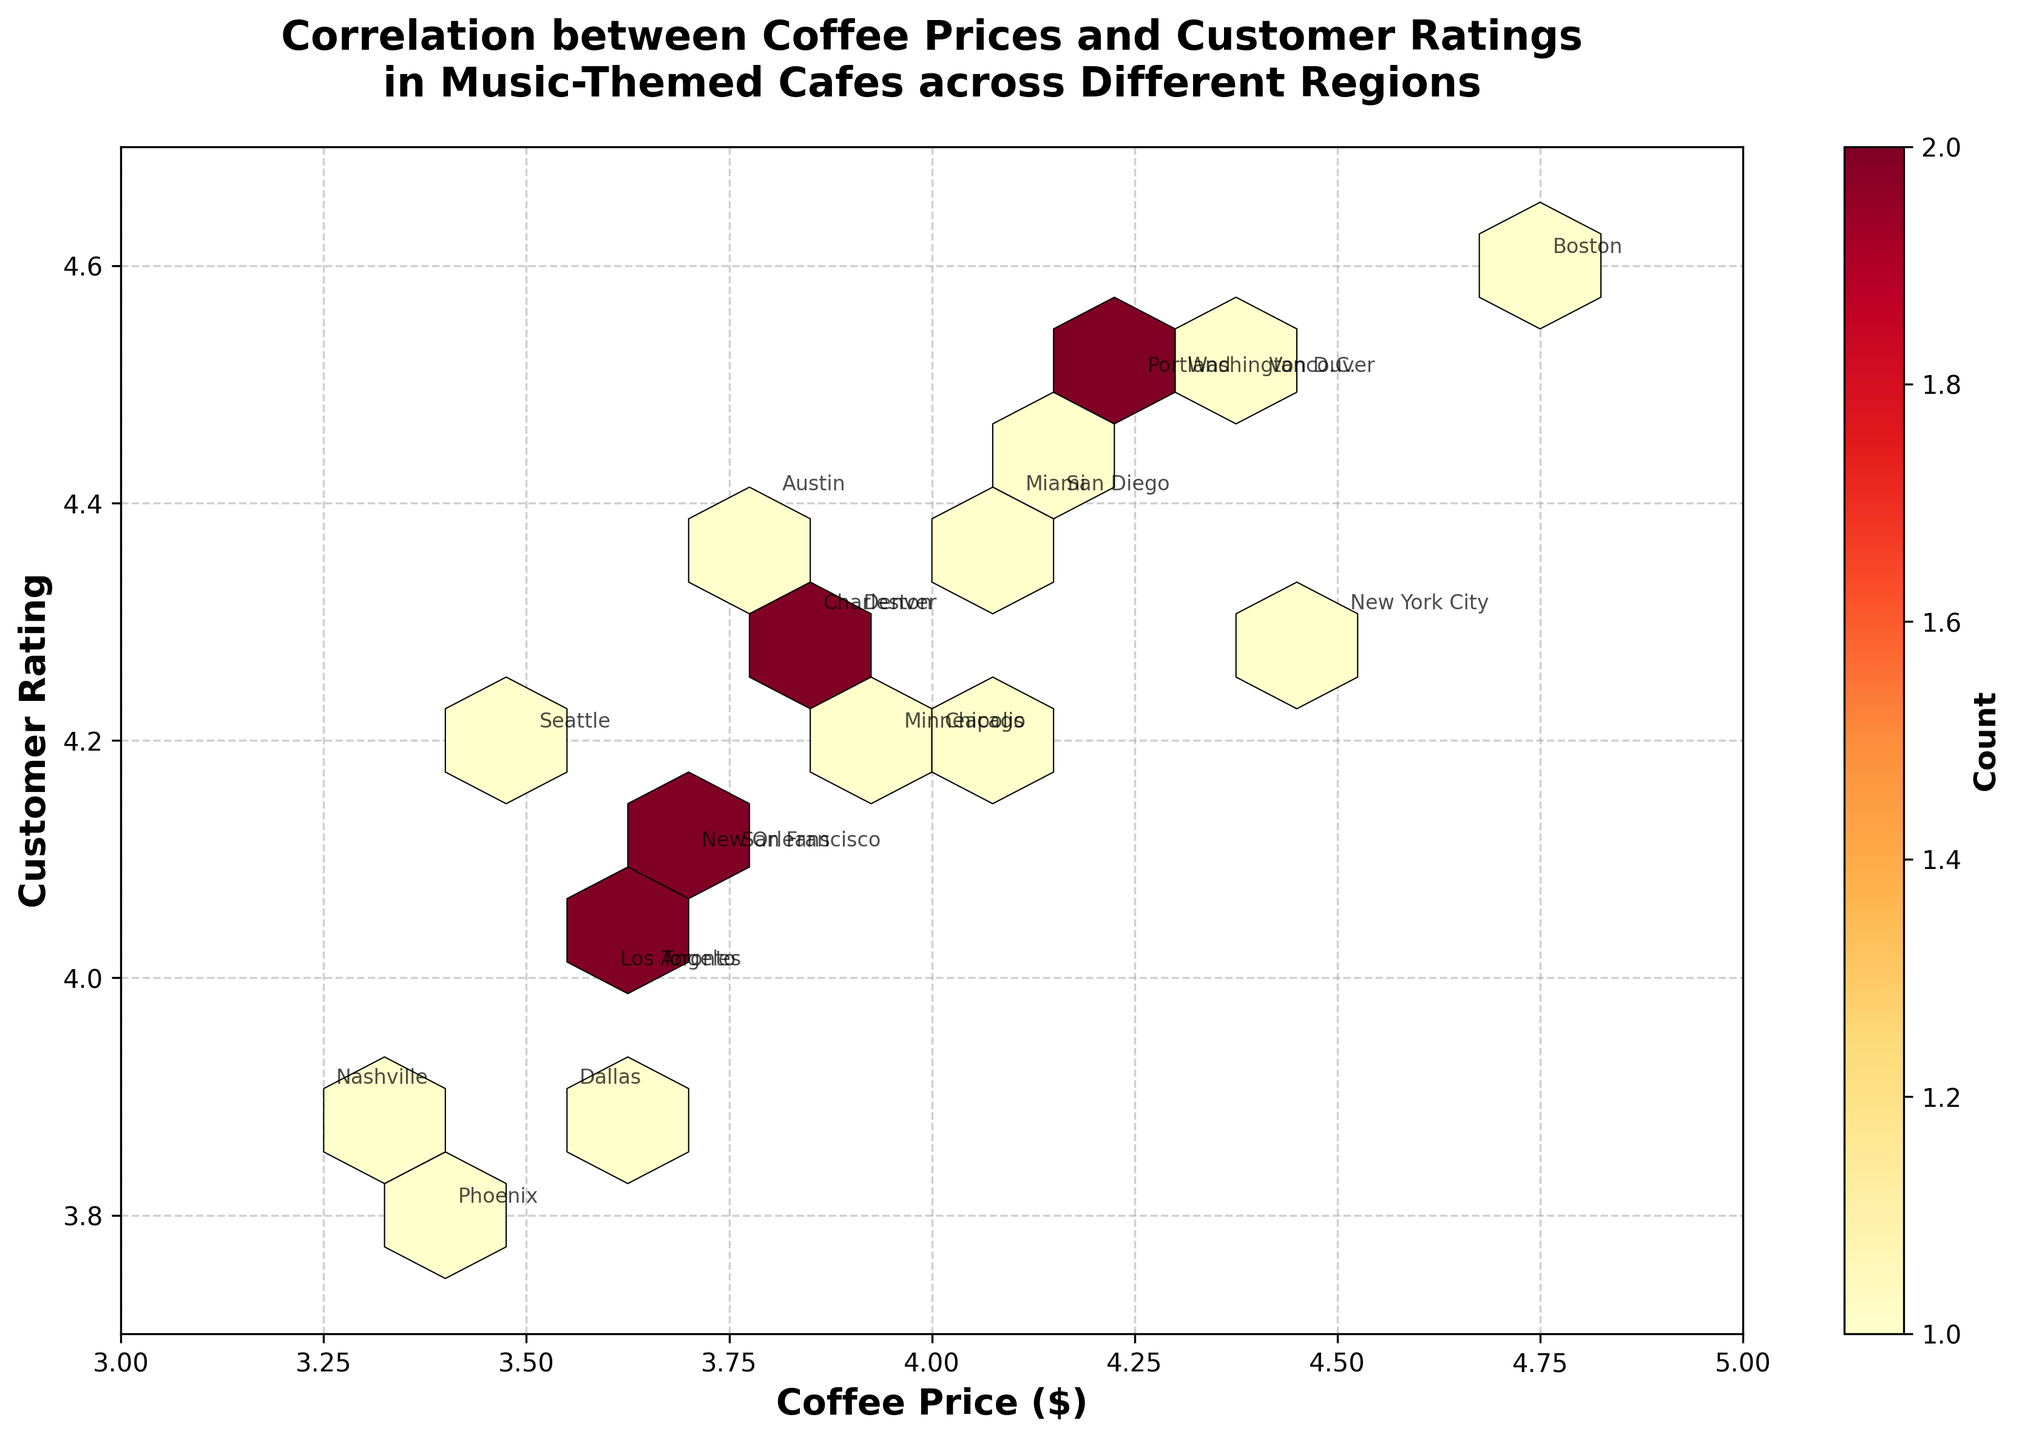What's the title of the plot? The title is typically found at the top of the plot and provides a concise summary of what the plot represents. From the provided information, the title is "Correlation between Coffee Prices and Customer Ratings in Music-Themed Cafes across Different Regions".
Answer: Correlation between Coffee Prices and Customer Ratings in Music-Themed Cafes across Different Regions What are the x and y-axis labels? Axis labels are located along the x-axis and y-axis to describe what each axis represents. The x-axis label is "Coffee Price ($)" and the y-axis label is "Customer Rating".
Answer: Coffee Price ($), Customer Rating How many unique regions are annotated in the plot? To determine the number of unique regions, we look at the annotations within the plot. Each annotation represents a unique region. From the data, there are 20 unique regions.
Answer: 20 Which customer rating corresponds to the highest coffee price annotated in the plot? We locate the annotation with the highest coffee price, which is $4.75, and find the corresponding customer rating, which is 4.6 for Boston.
Answer: 4.6 What is the color used to represent the highest density of hexagons in the plot? Colors in a hexbin plot typically indicate density, with darker or more intense colors representing higher densities. According to the provided code, the colormap 'YlOrRd' is used, where the highest density is represented by red.
Answer: Red What is the range of customer ratings covered in the plot? To determine the range, we look at the y-axis limits, which were set in the code. The customer ratings range from 3.7 to 4.7.
Answer: 3.7 to 4.7 What is the approximate coffee price and customer rating in Seattle based on the annotations? Annotations are directly labeled on the plot. From the data, Seattle has a coffee price of $3.50 and a customer rating of 4.2.
Answer: $3.50, 4.2 Between Chicago and New York City, which region has a higher customer rating? Both region annotations can be checked. Chicago has a customer rating of 4.2, while New York City has a rating of 4.3. Comparing these, New York City has the higher rating.
Answer: New York City How does the relationship between coffee price and customer rating appear, based on the density of hexagons? The hexbin plot's color intensity indicates density. If there's a region where hexagons are denser, it suggests a stronger correlation or frequent occurrence. The density pattern can indicate whether an increase in coffee price generally matches with a higher customer rating. From this plot, a positive correlation is suggested as higher prices tend to coincide with higher ratings.
Answer: Positive correlation Which region has the lowest customer rating annotated in the plot, and what is that rating? By checking the annotations for the lowest rating, Phoenix has the lowest customer rating of 3.8.
Answer: Phoenix, 3.8 